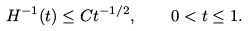Convert formula to latex. <formula><loc_0><loc_0><loc_500><loc_500>H ^ { - 1 } ( t ) \leq C t ^ { - 1 / 2 } , \quad 0 < t \leq 1 .</formula> 